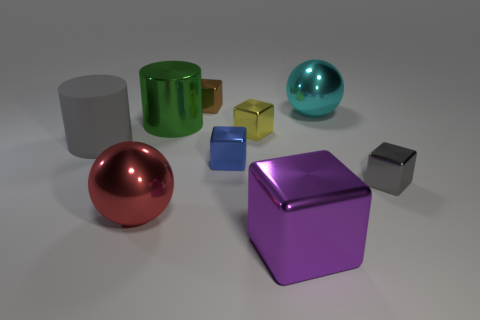Add 1 small gray blocks. How many objects exist? 10 Subtract all large blocks. How many blocks are left? 4 Subtract all cylinders. How many objects are left? 7 Subtract 1 spheres. How many spheres are left? 1 Subtract all purple blocks. How many blocks are left? 4 Subtract 1 blue blocks. How many objects are left? 8 Subtract all cyan spheres. Subtract all purple blocks. How many spheres are left? 1 Subtract all brown blocks. How many yellow balls are left? 0 Subtract all big blue spheres. Subtract all gray matte cylinders. How many objects are left? 8 Add 6 gray metal blocks. How many gray metal blocks are left? 7 